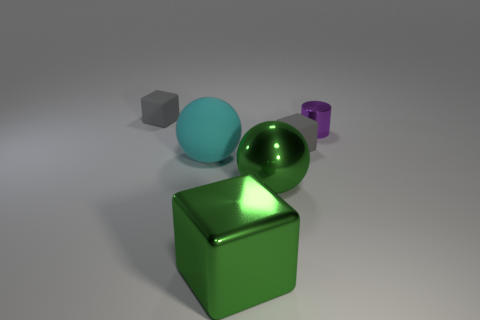Is there anything else that has the same shape as the tiny purple metallic object?
Your answer should be very brief. No. The tiny thing that is the same material as the green sphere is what color?
Give a very brief answer. Purple. How many green objects have the same material as the tiny purple object?
Keep it short and to the point. 2. There is a large cube in front of the tiny metallic cylinder; is it the same color as the large metal sphere?
Make the answer very short. Yes. What number of tiny metallic things are the same shape as the large cyan object?
Make the answer very short. 0. Is the number of tiny purple cylinders in front of the purple thing the same as the number of large yellow cylinders?
Your answer should be compact. Yes. There is a block that is the same size as the cyan rubber sphere; what color is it?
Keep it short and to the point. Green. Is there another object of the same shape as the large matte object?
Keep it short and to the point. Yes. What material is the small cube that is to the left of the small gray matte cube that is in front of the tiny matte thing that is on the left side of the large cyan matte thing?
Provide a succinct answer. Rubber. What number of other things are the same size as the cyan rubber thing?
Give a very brief answer. 2. 